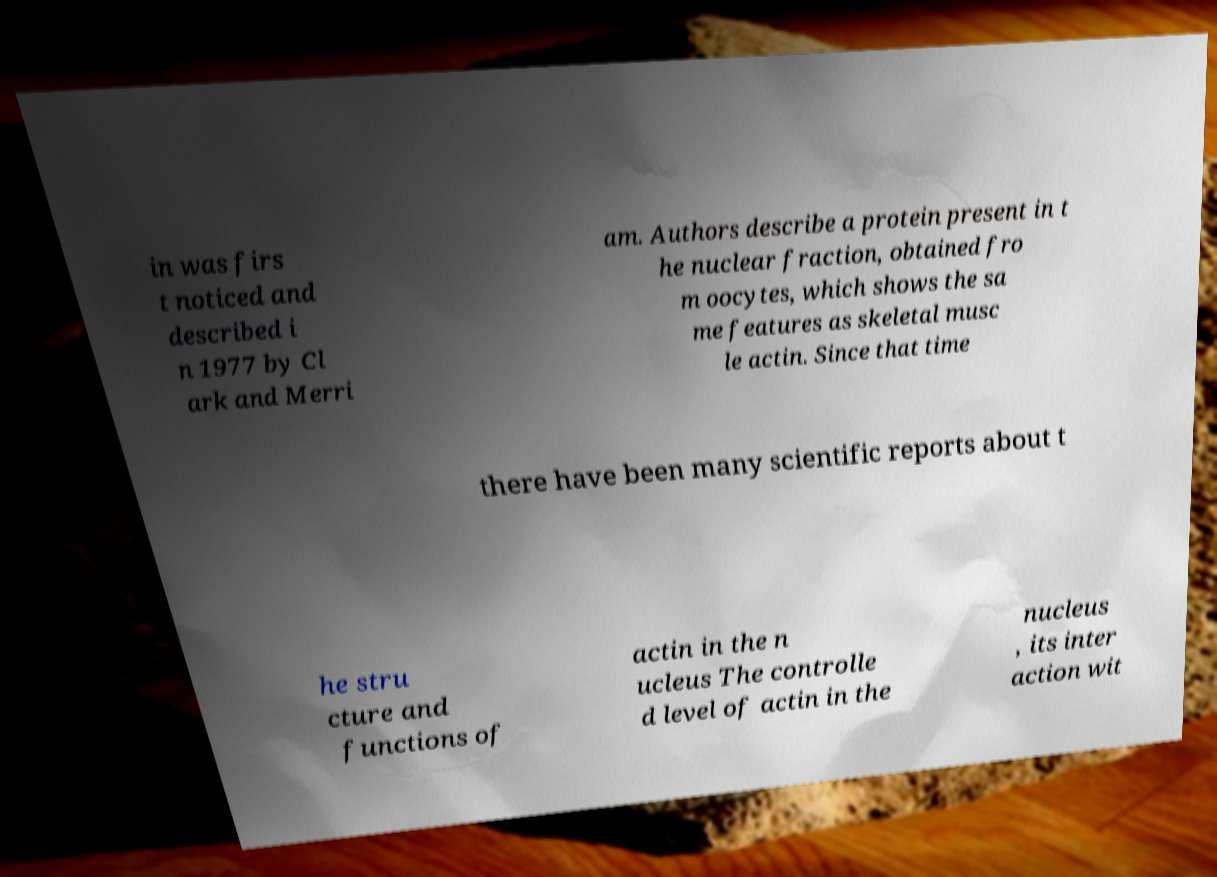Please identify and transcribe the text found in this image. in was firs t noticed and described i n 1977 by Cl ark and Merri am. Authors describe a protein present in t he nuclear fraction, obtained fro m oocytes, which shows the sa me features as skeletal musc le actin. Since that time there have been many scientific reports about t he stru cture and functions of actin in the n ucleus The controlle d level of actin in the nucleus , its inter action wit 